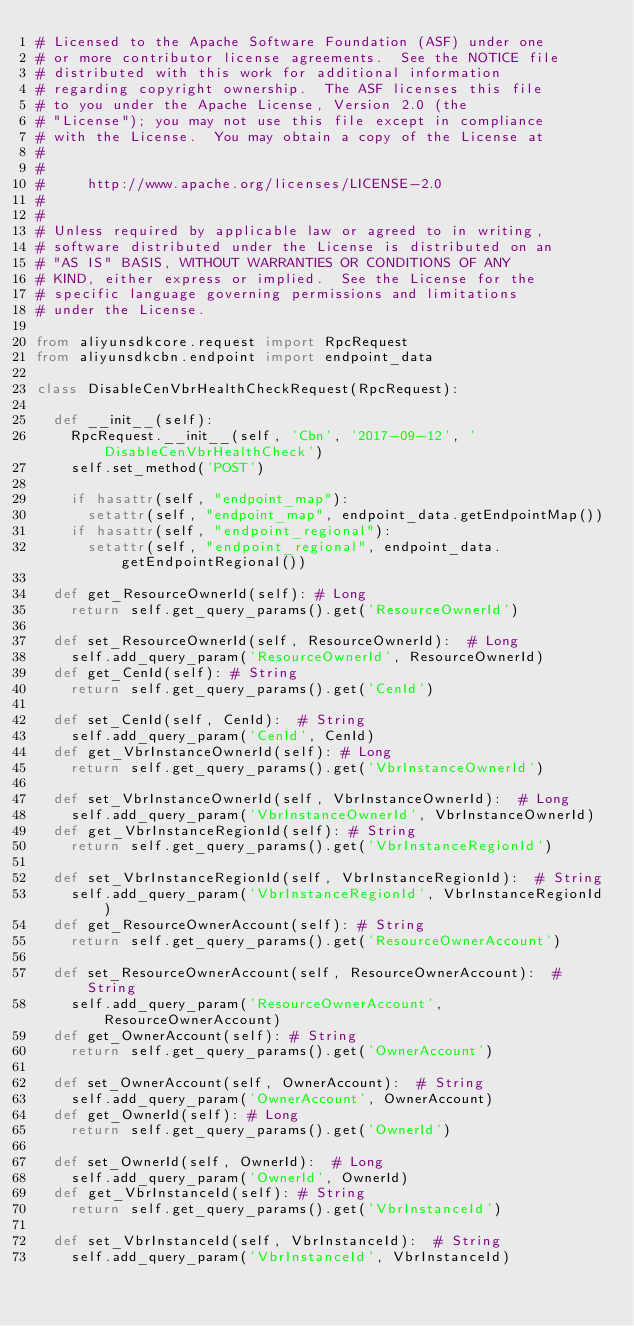Convert code to text. <code><loc_0><loc_0><loc_500><loc_500><_Python_># Licensed to the Apache Software Foundation (ASF) under one
# or more contributor license agreements.  See the NOTICE file
# distributed with this work for additional information
# regarding copyright ownership.  The ASF licenses this file
# to you under the Apache License, Version 2.0 (the
# "License"); you may not use this file except in compliance
# with the License.  You may obtain a copy of the License at
#
#
#     http://www.apache.org/licenses/LICENSE-2.0
#
#
# Unless required by applicable law or agreed to in writing,
# software distributed under the License is distributed on an
# "AS IS" BASIS, WITHOUT WARRANTIES OR CONDITIONS OF ANY
# KIND, either express or implied.  See the License for the
# specific language governing permissions and limitations
# under the License.

from aliyunsdkcore.request import RpcRequest
from aliyunsdkcbn.endpoint import endpoint_data

class DisableCenVbrHealthCheckRequest(RpcRequest):

	def __init__(self):
		RpcRequest.__init__(self, 'Cbn', '2017-09-12', 'DisableCenVbrHealthCheck')
		self.set_method('POST')

		if hasattr(self, "endpoint_map"):
			setattr(self, "endpoint_map", endpoint_data.getEndpointMap())
		if hasattr(self, "endpoint_regional"):
			setattr(self, "endpoint_regional", endpoint_data.getEndpointRegional())

	def get_ResourceOwnerId(self): # Long
		return self.get_query_params().get('ResourceOwnerId')

	def set_ResourceOwnerId(self, ResourceOwnerId):  # Long
		self.add_query_param('ResourceOwnerId', ResourceOwnerId)
	def get_CenId(self): # String
		return self.get_query_params().get('CenId')

	def set_CenId(self, CenId):  # String
		self.add_query_param('CenId', CenId)
	def get_VbrInstanceOwnerId(self): # Long
		return self.get_query_params().get('VbrInstanceOwnerId')

	def set_VbrInstanceOwnerId(self, VbrInstanceOwnerId):  # Long
		self.add_query_param('VbrInstanceOwnerId', VbrInstanceOwnerId)
	def get_VbrInstanceRegionId(self): # String
		return self.get_query_params().get('VbrInstanceRegionId')

	def set_VbrInstanceRegionId(self, VbrInstanceRegionId):  # String
		self.add_query_param('VbrInstanceRegionId', VbrInstanceRegionId)
	def get_ResourceOwnerAccount(self): # String
		return self.get_query_params().get('ResourceOwnerAccount')

	def set_ResourceOwnerAccount(self, ResourceOwnerAccount):  # String
		self.add_query_param('ResourceOwnerAccount', ResourceOwnerAccount)
	def get_OwnerAccount(self): # String
		return self.get_query_params().get('OwnerAccount')

	def set_OwnerAccount(self, OwnerAccount):  # String
		self.add_query_param('OwnerAccount', OwnerAccount)
	def get_OwnerId(self): # Long
		return self.get_query_params().get('OwnerId')

	def set_OwnerId(self, OwnerId):  # Long
		self.add_query_param('OwnerId', OwnerId)
	def get_VbrInstanceId(self): # String
		return self.get_query_params().get('VbrInstanceId')

	def set_VbrInstanceId(self, VbrInstanceId):  # String
		self.add_query_param('VbrInstanceId', VbrInstanceId)
</code> 